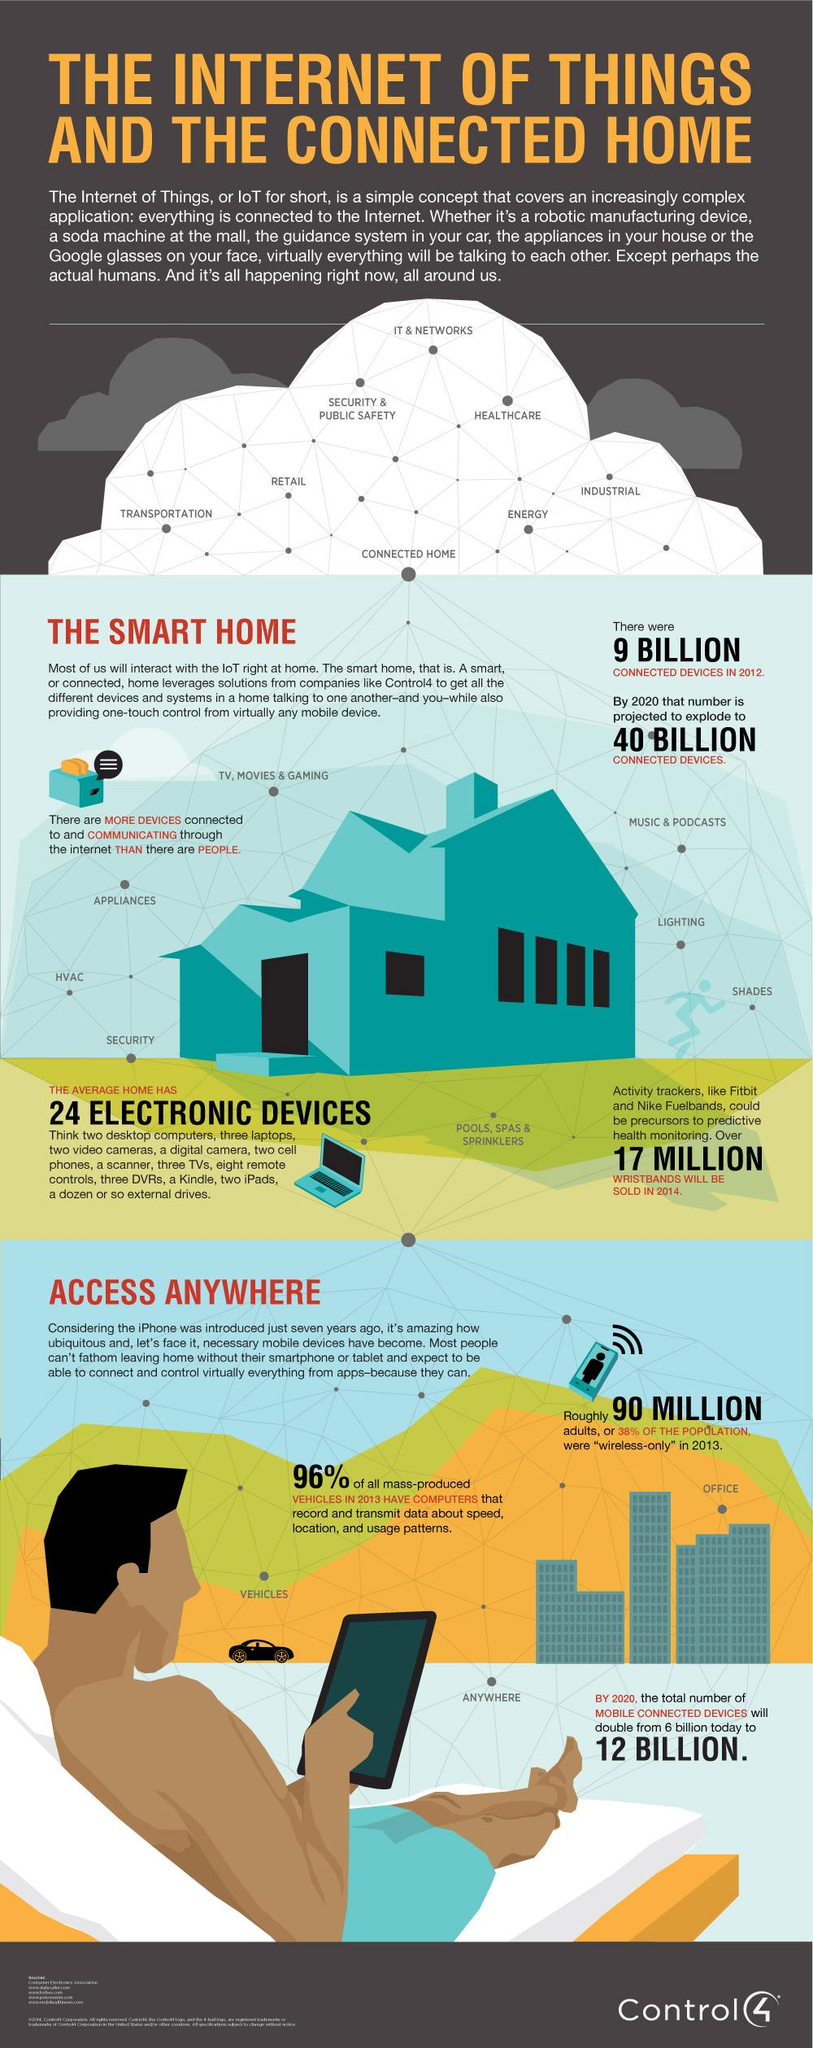List a handful of essential elements in this visual. Fitbit and Nike Fuelbands are activity trackers that measure and record an individual's physical activity levels. What is the man holding in his hand? A tablet. By 2020, it is projected that the number of connected devices will increase significantly, reaching billions, as compared to the number in 2012. The color of the toaster is blue, not yellow. Approximately 30% of the population is equivalent to 90 million people. 